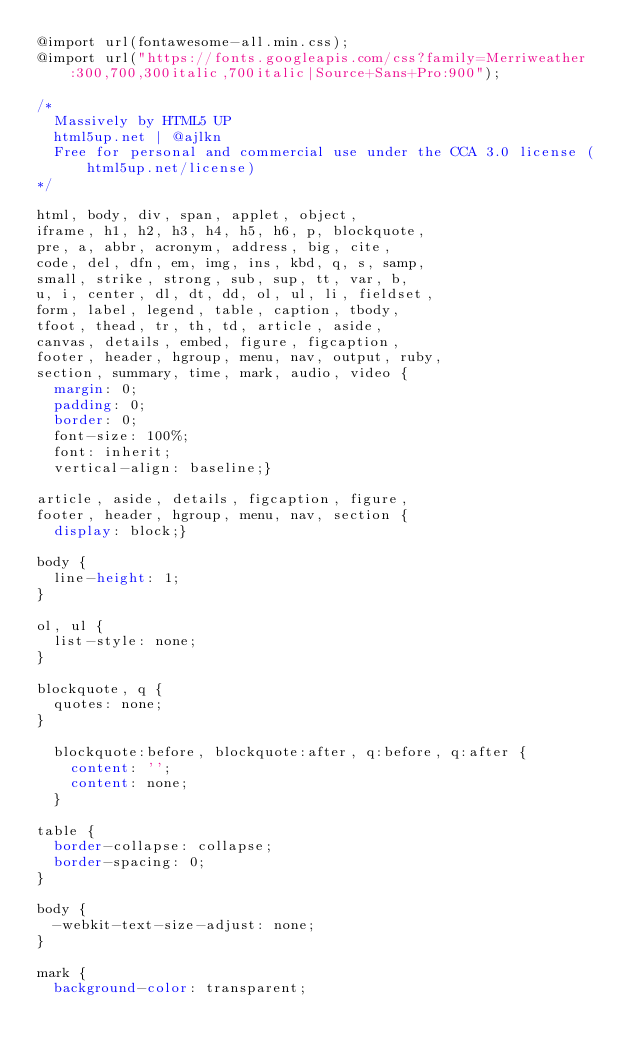<code> <loc_0><loc_0><loc_500><loc_500><_CSS_>@import url(fontawesome-all.min.css);
@import url("https://fonts.googleapis.com/css?family=Merriweather:300,700,300italic,700italic|Source+Sans+Pro:900");

/*
	Massively by HTML5 UP
	html5up.net | @ajlkn
	Free for personal and commercial use under the CCA 3.0 license (html5up.net/license)
*/

html, body, div, span, applet, object,
iframe, h1, h2, h3, h4, h5, h6, p, blockquote,
pre, a, abbr, acronym, address, big, cite,
code, del, dfn, em, img, ins, kbd, q, s, samp,
small, strike, strong, sub, sup, tt, var, b,
u, i, center, dl, dt, dd, ol, ul, li, fieldset,
form, label, legend, table, caption, tbody,
tfoot, thead, tr, th, td, article, aside,
canvas, details, embed, figure, figcaption,
footer, header, hgroup, menu, nav, output, ruby,
section, summary, time, mark, audio, video {
	margin: 0;
	padding: 0;
	border: 0;
	font-size: 100%;
	font: inherit;
	vertical-align: baseline;}

article, aside, details, figcaption, figure,
footer, header, hgroup, menu, nav, section {
	display: block;}

body {
	line-height: 1;
}

ol, ul {
	list-style: none;
}

blockquote, q {
	quotes: none;
}

	blockquote:before, blockquote:after, q:before, q:after {
		content: '';
		content: none;
	}

table {
	border-collapse: collapse;
	border-spacing: 0;
}

body {
	-webkit-text-size-adjust: none;
}

mark {
	background-color: transparent;</code> 